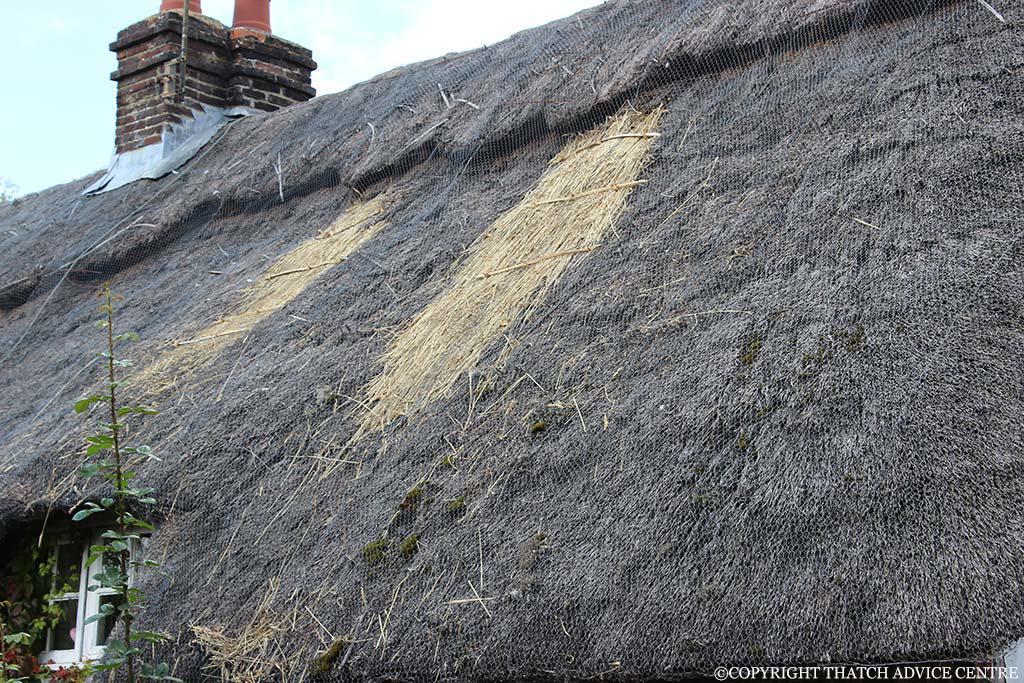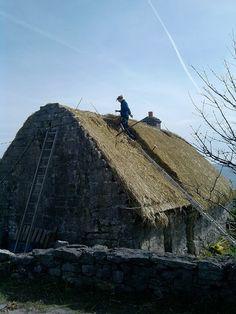The first image is the image on the left, the second image is the image on the right. Evaluate the accuracy of this statement regarding the images: "At least one person is standing on the ground outside of a building in one of the images.". Is it true? Answer yes or no. No. 